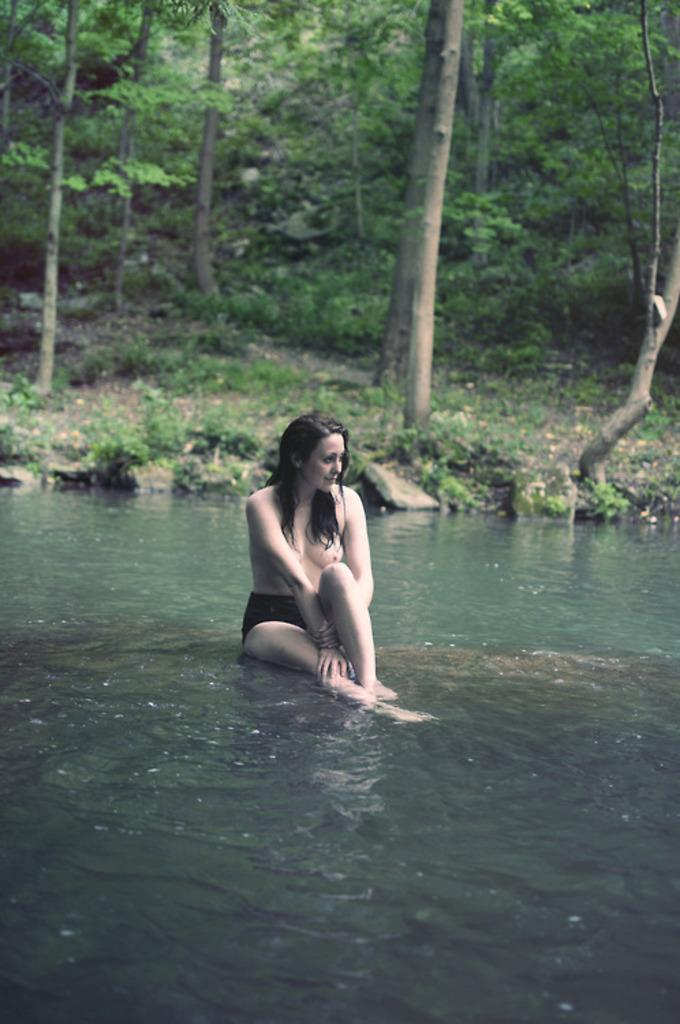What is the woman doing in the image? The woman is sitting in the image. What can be seen at the bottom of the image? There is water visible at the bottom of the image. What is visible in the background of the image? There are trees and plants in the background of the image. What type of rice can be seen in the woman's hand in the image? There is no rice present in the image, and the woman's hands are not visible. 